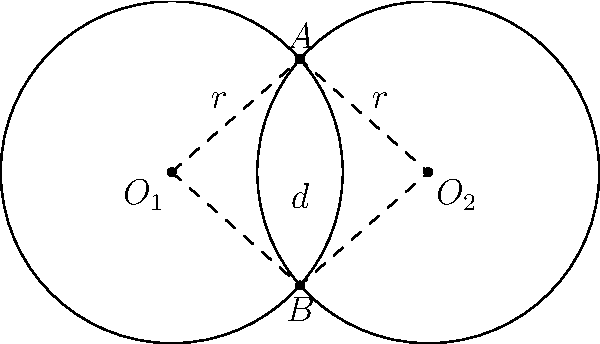Melinda, remember our discussion about circle congruence? Here's an interesting problem: Two circles with centers $O_1$ and $O_2$ have equal radii $r$ and intersect at points $A$ and $B$. If the distance between the centers is $d$, what is the relationship between $d$ and $r$ for the circles to be tangent externally? Let's approach this step-by-step:

1) In the case of external tangency, the circles would touch at exactly one point. This means points $A$ and $B$ would coincide.

2) In this scenario, the line segment connecting the centers ($O_1O_2$) would be equal to the sum of the radii of both circles.

3) Since both circles have the same radius $r$, we can express this as:

   $d = r + r = 2r$

4) Therefore, for the circles to be tangent externally, the distance between their centers must be exactly twice the radius of either circle.

5) If $d < 2r$, the circles would intersect at two distinct points.
   If $d > 2r$, the circles would be separate with no intersection.
   If $d = 2r$, we have the case of external tangency.

This relationship ($d = 2r$) is crucial in many geometric constructions and proofs involving tangent circles.
Answer: $d = 2r$ 